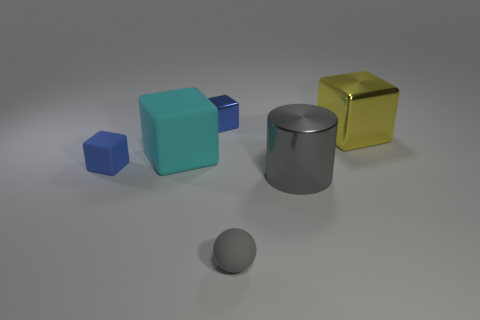Subtract all cyan matte blocks. How many blocks are left? 3 Add 1 tiny metallic blocks. How many objects exist? 7 Subtract all yellow blocks. How many blocks are left? 3 Subtract 2 cubes. How many cubes are left? 2 Subtract all cylinders. How many objects are left? 5 Subtract all brown cylinders. How many brown cubes are left? 0 Subtract all small gray things. Subtract all small blue things. How many objects are left? 3 Add 4 gray balls. How many gray balls are left? 5 Add 3 large purple metallic blocks. How many large purple metallic blocks exist? 3 Subtract 1 gray spheres. How many objects are left? 5 